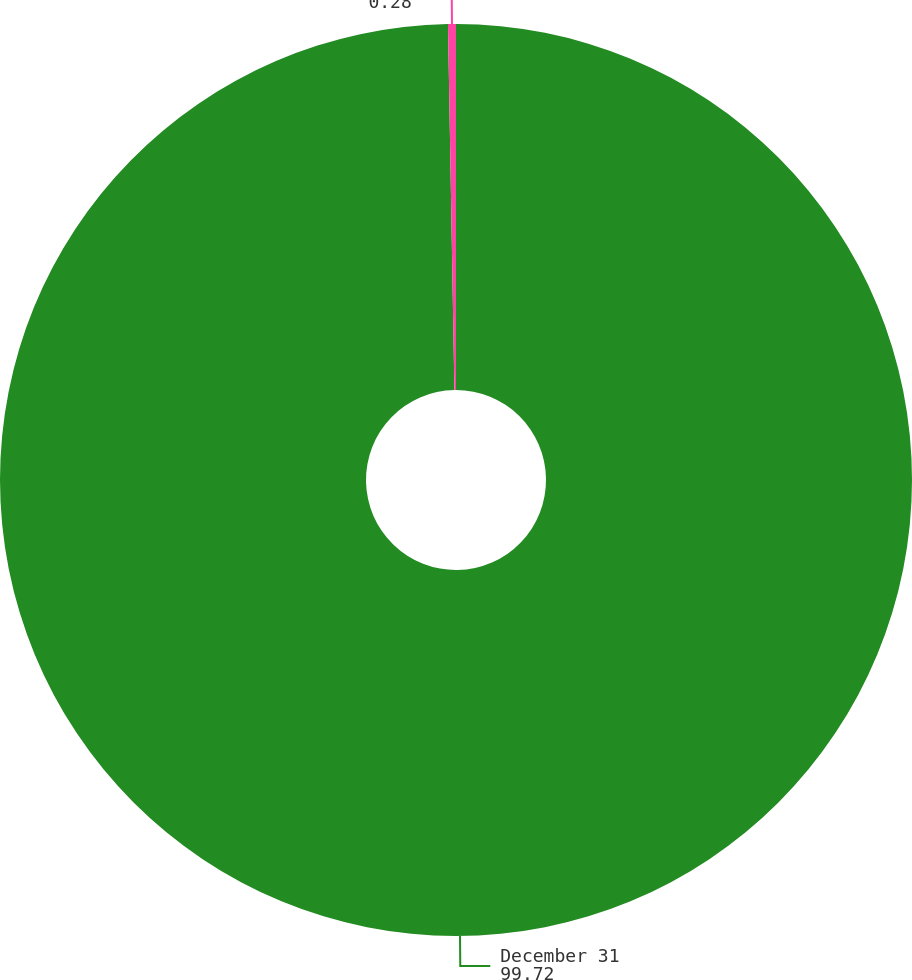Convert chart to OTSL. <chart><loc_0><loc_0><loc_500><loc_500><pie_chart><fcel>December 31<fcel>Discount rate<nl><fcel>99.72%<fcel>0.28%<nl></chart> 